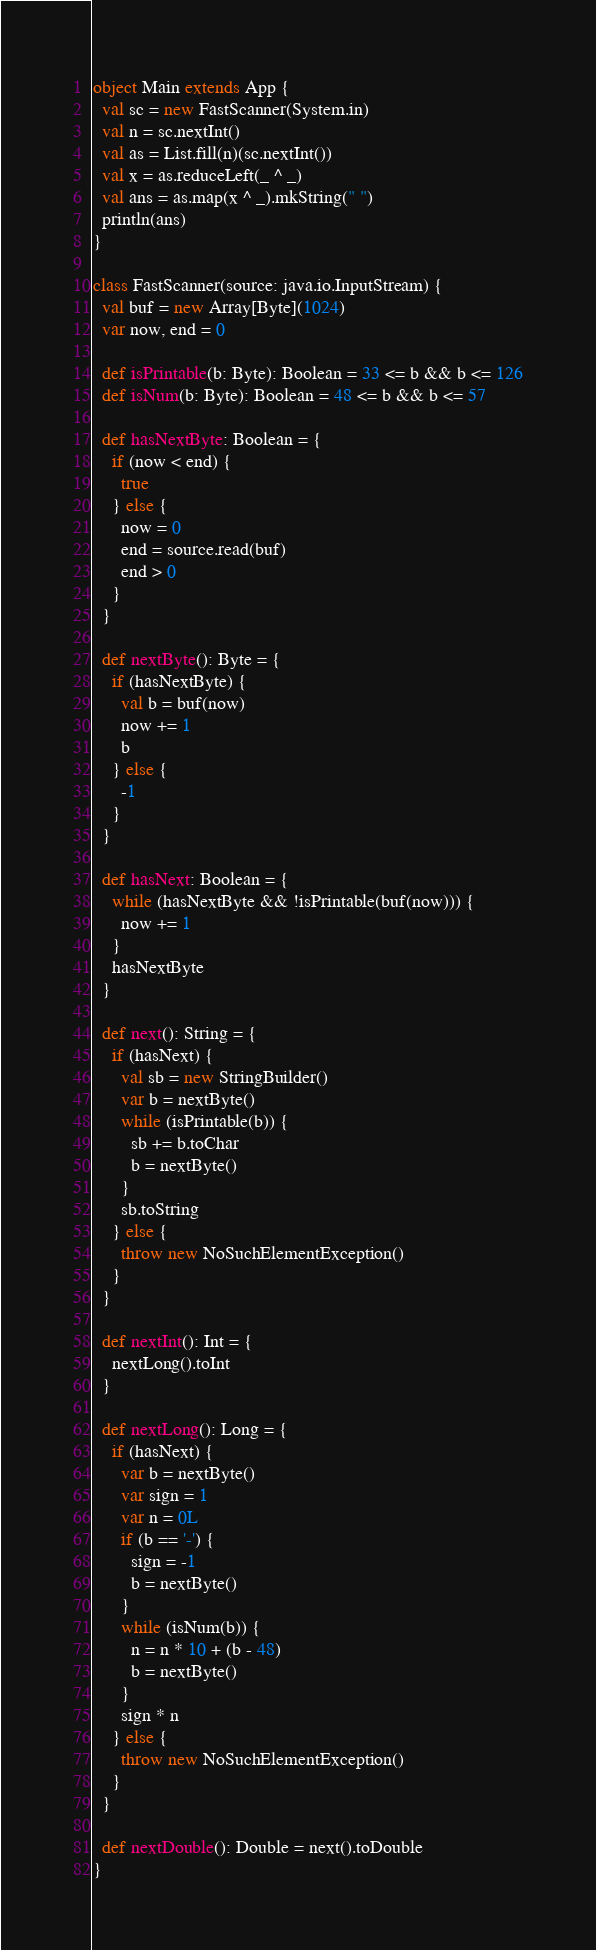<code> <loc_0><loc_0><loc_500><loc_500><_Scala_>object Main extends App {
  val sc = new FastScanner(System.in)
  val n = sc.nextInt()
  val as = List.fill(n)(sc.nextInt())
  val x = as.reduceLeft(_ ^ _)
  val ans = as.map(x ^ _).mkString(" ")
  println(ans)
}

class FastScanner(source: java.io.InputStream) {
  val buf = new Array[Byte](1024)
  var now, end = 0

  def isPrintable(b: Byte): Boolean = 33 <= b && b <= 126
  def isNum(b: Byte): Boolean = 48 <= b && b <= 57

  def hasNextByte: Boolean = {
    if (now < end) {
      true
    } else {
      now = 0
      end = source.read(buf)
      end > 0
    }
  }

  def nextByte(): Byte = {
    if (hasNextByte) {
      val b = buf(now)
      now += 1
      b
    } else {
      -1
    }
  }

  def hasNext: Boolean = {
    while (hasNextByte && !isPrintable(buf(now))) {
      now += 1
    }
    hasNextByte
  }

  def next(): String = {
    if (hasNext) {
      val sb = new StringBuilder()
      var b = nextByte()
      while (isPrintable(b)) {
        sb += b.toChar
        b = nextByte()
      }
      sb.toString
    } else {
      throw new NoSuchElementException()
    }
  }

  def nextInt(): Int = {
    nextLong().toInt
  }

  def nextLong(): Long = {
    if (hasNext) {
      var b = nextByte()
      var sign = 1
      var n = 0L
      if (b == '-') {
        sign = -1
        b = nextByte()
      }
      while (isNum(b)) {
        n = n * 10 + (b - 48)
        b = nextByte()
      }
      sign * n
    } else {
      throw new NoSuchElementException()
    }
  }

  def nextDouble(): Double = next().toDouble
}
</code> 